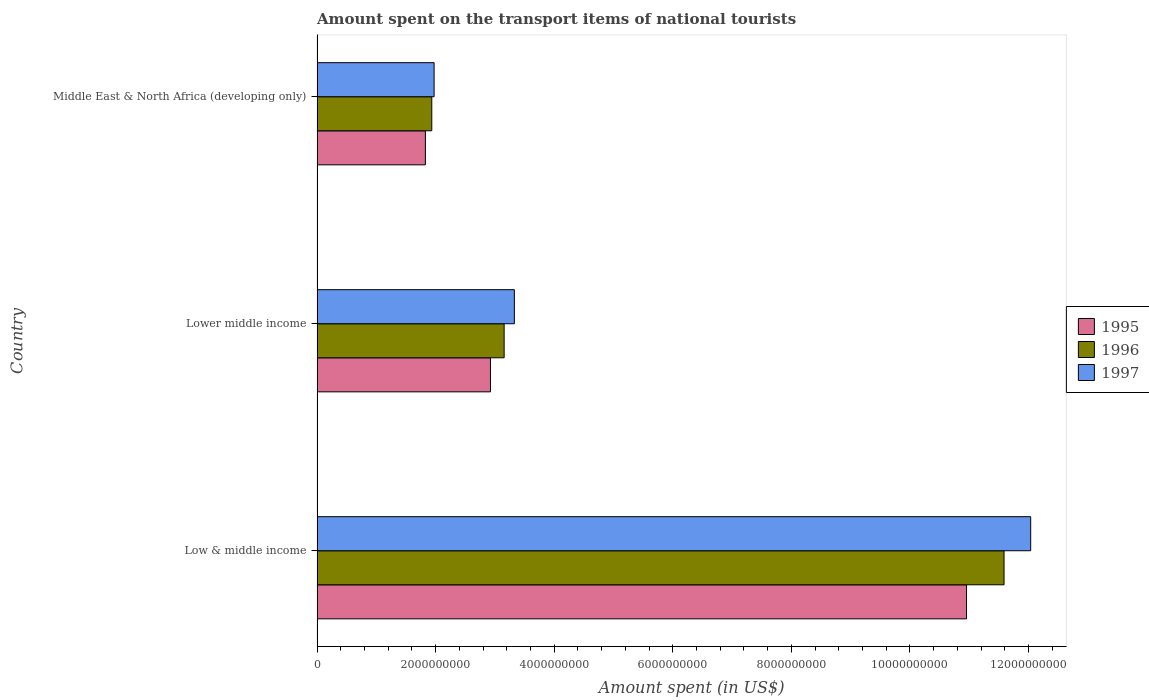Are the number of bars per tick equal to the number of legend labels?
Your answer should be very brief. Yes. Are the number of bars on each tick of the Y-axis equal?
Keep it short and to the point. Yes. In how many cases, is the number of bars for a given country not equal to the number of legend labels?
Ensure brevity in your answer.  0. What is the amount spent on the transport items of national tourists in 1997 in Middle East & North Africa (developing only)?
Keep it short and to the point. 1.97e+09. Across all countries, what is the maximum amount spent on the transport items of national tourists in 1996?
Keep it short and to the point. 1.16e+1. Across all countries, what is the minimum amount spent on the transport items of national tourists in 1997?
Keep it short and to the point. 1.97e+09. In which country was the amount spent on the transport items of national tourists in 1997 maximum?
Offer a very short reply. Low & middle income. In which country was the amount spent on the transport items of national tourists in 1997 minimum?
Ensure brevity in your answer.  Middle East & North Africa (developing only). What is the total amount spent on the transport items of national tourists in 1995 in the graph?
Offer a terse response. 1.57e+1. What is the difference between the amount spent on the transport items of national tourists in 1996 in Low & middle income and that in Middle East & North Africa (developing only)?
Offer a very short reply. 9.65e+09. What is the difference between the amount spent on the transport items of national tourists in 1995 in Lower middle income and the amount spent on the transport items of national tourists in 1996 in Low & middle income?
Your answer should be compact. -8.66e+09. What is the average amount spent on the transport items of national tourists in 1997 per country?
Your response must be concise. 5.78e+09. What is the difference between the amount spent on the transport items of national tourists in 1995 and amount spent on the transport items of national tourists in 1997 in Low & middle income?
Give a very brief answer. -1.08e+09. In how many countries, is the amount spent on the transport items of national tourists in 1996 greater than 11200000000 US$?
Your answer should be very brief. 1. What is the ratio of the amount spent on the transport items of national tourists in 1995 in Lower middle income to that in Middle East & North Africa (developing only)?
Your answer should be compact. 1.6. Is the amount spent on the transport items of national tourists in 1996 in Lower middle income less than that in Middle East & North Africa (developing only)?
Your answer should be compact. No. Is the difference between the amount spent on the transport items of national tourists in 1995 in Low & middle income and Lower middle income greater than the difference between the amount spent on the transport items of national tourists in 1997 in Low & middle income and Lower middle income?
Offer a terse response. No. What is the difference between the highest and the second highest amount spent on the transport items of national tourists in 1995?
Ensure brevity in your answer.  8.03e+09. What is the difference between the highest and the lowest amount spent on the transport items of national tourists in 1997?
Give a very brief answer. 1.01e+1. Is the sum of the amount spent on the transport items of national tourists in 1995 in Low & middle income and Lower middle income greater than the maximum amount spent on the transport items of national tourists in 1997 across all countries?
Keep it short and to the point. Yes. Is it the case that in every country, the sum of the amount spent on the transport items of national tourists in 1995 and amount spent on the transport items of national tourists in 1996 is greater than the amount spent on the transport items of national tourists in 1997?
Offer a very short reply. Yes. Are all the bars in the graph horizontal?
Offer a terse response. Yes. How many countries are there in the graph?
Keep it short and to the point. 3. Does the graph contain any zero values?
Provide a succinct answer. No. Where does the legend appear in the graph?
Your answer should be compact. Center right. How many legend labels are there?
Your answer should be very brief. 3. How are the legend labels stacked?
Your response must be concise. Vertical. What is the title of the graph?
Ensure brevity in your answer.  Amount spent on the transport items of national tourists. What is the label or title of the X-axis?
Your response must be concise. Amount spent (in US$). What is the label or title of the Y-axis?
Your answer should be very brief. Country. What is the Amount spent (in US$) of 1995 in Low & middle income?
Offer a terse response. 1.10e+1. What is the Amount spent (in US$) of 1996 in Low & middle income?
Ensure brevity in your answer.  1.16e+1. What is the Amount spent (in US$) of 1997 in Low & middle income?
Ensure brevity in your answer.  1.20e+1. What is the Amount spent (in US$) in 1995 in Lower middle income?
Give a very brief answer. 2.92e+09. What is the Amount spent (in US$) in 1996 in Lower middle income?
Your response must be concise. 3.16e+09. What is the Amount spent (in US$) in 1997 in Lower middle income?
Your response must be concise. 3.33e+09. What is the Amount spent (in US$) of 1995 in Middle East & North Africa (developing only)?
Provide a short and direct response. 1.83e+09. What is the Amount spent (in US$) of 1996 in Middle East & North Africa (developing only)?
Your response must be concise. 1.94e+09. What is the Amount spent (in US$) of 1997 in Middle East & North Africa (developing only)?
Give a very brief answer. 1.97e+09. Across all countries, what is the maximum Amount spent (in US$) in 1995?
Offer a terse response. 1.10e+1. Across all countries, what is the maximum Amount spent (in US$) in 1996?
Provide a short and direct response. 1.16e+1. Across all countries, what is the maximum Amount spent (in US$) in 1997?
Make the answer very short. 1.20e+1. Across all countries, what is the minimum Amount spent (in US$) in 1995?
Your answer should be compact. 1.83e+09. Across all countries, what is the minimum Amount spent (in US$) of 1996?
Give a very brief answer. 1.94e+09. Across all countries, what is the minimum Amount spent (in US$) of 1997?
Provide a succinct answer. 1.97e+09. What is the total Amount spent (in US$) in 1995 in the graph?
Make the answer very short. 1.57e+1. What is the total Amount spent (in US$) of 1996 in the graph?
Your answer should be very brief. 1.67e+1. What is the total Amount spent (in US$) of 1997 in the graph?
Ensure brevity in your answer.  1.73e+1. What is the difference between the Amount spent (in US$) in 1995 in Low & middle income and that in Lower middle income?
Offer a terse response. 8.03e+09. What is the difference between the Amount spent (in US$) of 1996 in Low & middle income and that in Lower middle income?
Keep it short and to the point. 8.43e+09. What is the difference between the Amount spent (in US$) of 1997 in Low & middle income and that in Lower middle income?
Ensure brevity in your answer.  8.71e+09. What is the difference between the Amount spent (in US$) of 1995 in Low & middle income and that in Middle East & North Africa (developing only)?
Provide a succinct answer. 9.13e+09. What is the difference between the Amount spent (in US$) in 1996 in Low & middle income and that in Middle East & North Africa (developing only)?
Your response must be concise. 9.65e+09. What is the difference between the Amount spent (in US$) in 1997 in Low & middle income and that in Middle East & North Africa (developing only)?
Provide a short and direct response. 1.01e+1. What is the difference between the Amount spent (in US$) in 1995 in Lower middle income and that in Middle East & North Africa (developing only)?
Give a very brief answer. 1.10e+09. What is the difference between the Amount spent (in US$) of 1996 in Lower middle income and that in Middle East & North Africa (developing only)?
Your response must be concise. 1.22e+09. What is the difference between the Amount spent (in US$) of 1997 in Lower middle income and that in Middle East & North Africa (developing only)?
Provide a succinct answer. 1.35e+09. What is the difference between the Amount spent (in US$) in 1995 in Low & middle income and the Amount spent (in US$) in 1996 in Lower middle income?
Ensure brevity in your answer.  7.80e+09. What is the difference between the Amount spent (in US$) in 1995 in Low & middle income and the Amount spent (in US$) in 1997 in Lower middle income?
Offer a very short reply. 7.63e+09. What is the difference between the Amount spent (in US$) in 1996 in Low & middle income and the Amount spent (in US$) in 1997 in Lower middle income?
Ensure brevity in your answer.  8.26e+09. What is the difference between the Amount spent (in US$) of 1995 in Low & middle income and the Amount spent (in US$) of 1996 in Middle East & North Africa (developing only)?
Make the answer very short. 9.02e+09. What is the difference between the Amount spent (in US$) in 1995 in Low & middle income and the Amount spent (in US$) in 1997 in Middle East & North Africa (developing only)?
Make the answer very short. 8.98e+09. What is the difference between the Amount spent (in US$) of 1996 in Low & middle income and the Amount spent (in US$) of 1997 in Middle East & North Africa (developing only)?
Provide a short and direct response. 9.61e+09. What is the difference between the Amount spent (in US$) in 1995 in Lower middle income and the Amount spent (in US$) in 1996 in Middle East & North Africa (developing only)?
Your answer should be compact. 9.90e+08. What is the difference between the Amount spent (in US$) in 1995 in Lower middle income and the Amount spent (in US$) in 1997 in Middle East & North Africa (developing only)?
Your response must be concise. 9.50e+08. What is the difference between the Amount spent (in US$) of 1996 in Lower middle income and the Amount spent (in US$) of 1997 in Middle East & North Africa (developing only)?
Make the answer very short. 1.18e+09. What is the average Amount spent (in US$) of 1995 per country?
Provide a succinct answer. 5.24e+09. What is the average Amount spent (in US$) in 1996 per country?
Offer a terse response. 5.56e+09. What is the average Amount spent (in US$) in 1997 per country?
Make the answer very short. 5.78e+09. What is the difference between the Amount spent (in US$) in 1995 and Amount spent (in US$) in 1996 in Low & middle income?
Make the answer very short. -6.33e+08. What is the difference between the Amount spent (in US$) of 1995 and Amount spent (in US$) of 1997 in Low & middle income?
Make the answer very short. -1.08e+09. What is the difference between the Amount spent (in US$) in 1996 and Amount spent (in US$) in 1997 in Low & middle income?
Provide a short and direct response. -4.49e+08. What is the difference between the Amount spent (in US$) of 1995 and Amount spent (in US$) of 1996 in Lower middle income?
Keep it short and to the point. -2.31e+08. What is the difference between the Amount spent (in US$) in 1995 and Amount spent (in US$) in 1997 in Lower middle income?
Keep it short and to the point. -4.03e+08. What is the difference between the Amount spent (in US$) of 1996 and Amount spent (in US$) of 1997 in Lower middle income?
Your answer should be very brief. -1.73e+08. What is the difference between the Amount spent (in US$) in 1995 and Amount spent (in US$) in 1996 in Middle East & North Africa (developing only)?
Give a very brief answer. -1.08e+08. What is the difference between the Amount spent (in US$) of 1995 and Amount spent (in US$) of 1997 in Middle East & North Africa (developing only)?
Provide a short and direct response. -1.47e+08. What is the difference between the Amount spent (in US$) in 1996 and Amount spent (in US$) in 1997 in Middle East & North Africa (developing only)?
Your answer should be very brief. -3.92e+07. What is the ratio of the Amount spent (in US$) of 1995 in Low & middle income to that in Lower middle income?
Offer a terse response. 3.75. What is the ratio of the Amount spent (in US$) of 1996 in Low & middle income to that in Lower middle income?
Offer a terse response. 3.67. What is the ratio of the Amount spent (in US$) in 1997 in Low & middle income to that in Lower middle income?
Offer a very short reply. 3.62. What is the ratio of the Amount spent (in US$) of 1995 in Low & middle income to that in Middle East & North Africa (developing only)?
Offer a very short reply. 5.99. What is the ratio of the Amount spent (in US$) in 1996 in Low & middle income to that in Middle East & North Africa (developing only)?
Your response must be concise. 5.99. What is the ratio of the Amount spent (in US$) of 1997 in Low & middle income to that in Middle East & North Africa (developing only)?
Provide a short and direct response. 6.1. What is the ratio of the Amount spent (in US$) of 1995 in Lower middle income to that in Middle East & North Africa (developing only)?
Ensure brevity in your answer.  1.6. What is the ratio of the Amount spent (in US$) of 1996 in Lower middle income to that in Middle East & North Africa (developing only)?
Make the answer very short. 1.63. What is the ratio of the Amount spent (in US$) of 1997 in Lower middle income to that in Middle East & North Africa (developing only)?
Ensure brevity in your answer.  1.69. What is the difference between the highest and the second highest Amount spent (in US$) of 1995?
Your answer should be compact. 8.03e+09. What is the difference between the highest and the second highest Amount spent (in US$) of 1996?
Offer a terse response. 8.43e+09. What is the difference between the highest and the second highest Amount spent (in US$) in 1997?
Keep it short and to the point. 8.71e+09. What is the difference between the highest and the lowest Amount spent (in US$) in 1995?
Keep it short and to the point. 9.13e+09. What is the difference between the highest and the lowest Amount spent (in US$) of 1996?
Offer a terse response. 9.65e+09. What is the difference between the highest and the lowest Amount spent (in US$) of 1997?
Offer a terse response. 1.01e+1. 